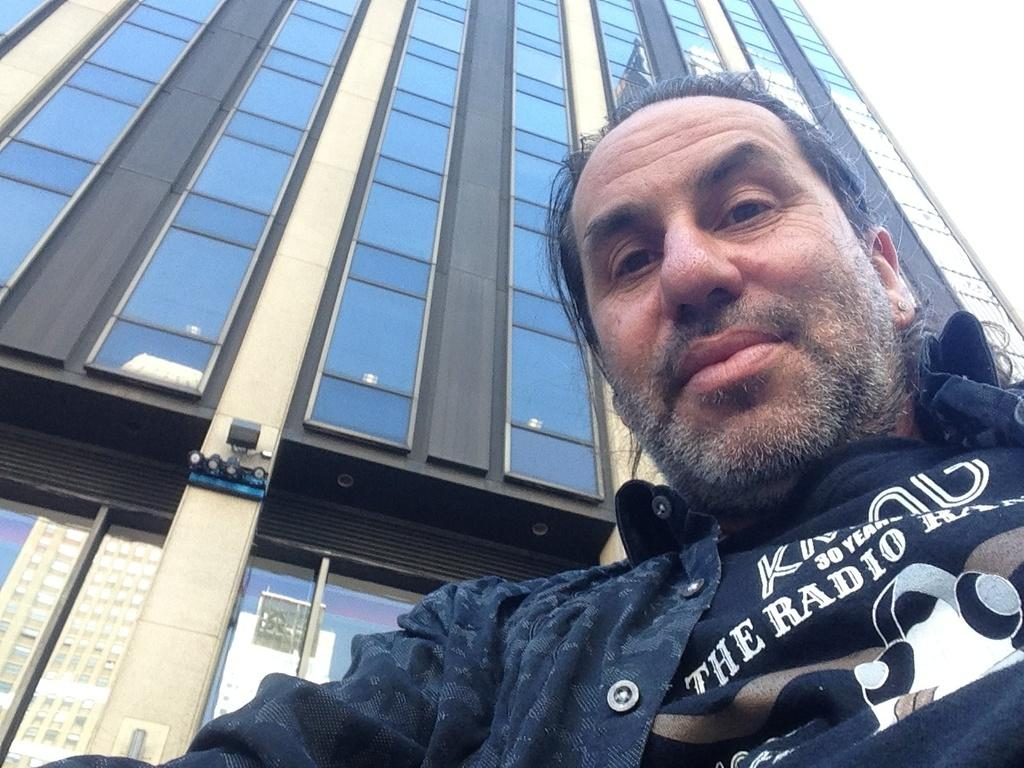What is present in the image? There is a person in the image. How is the person's expression? The person is smiling. What can be seen in the background of the image? There is a building in the background of the image. What type of slave is depicted in the image? There is no slave present in the image; it features a person who is smiling. What is the interest rate for the loan in the image? There is no mention of a loan or interest rate in the image. 